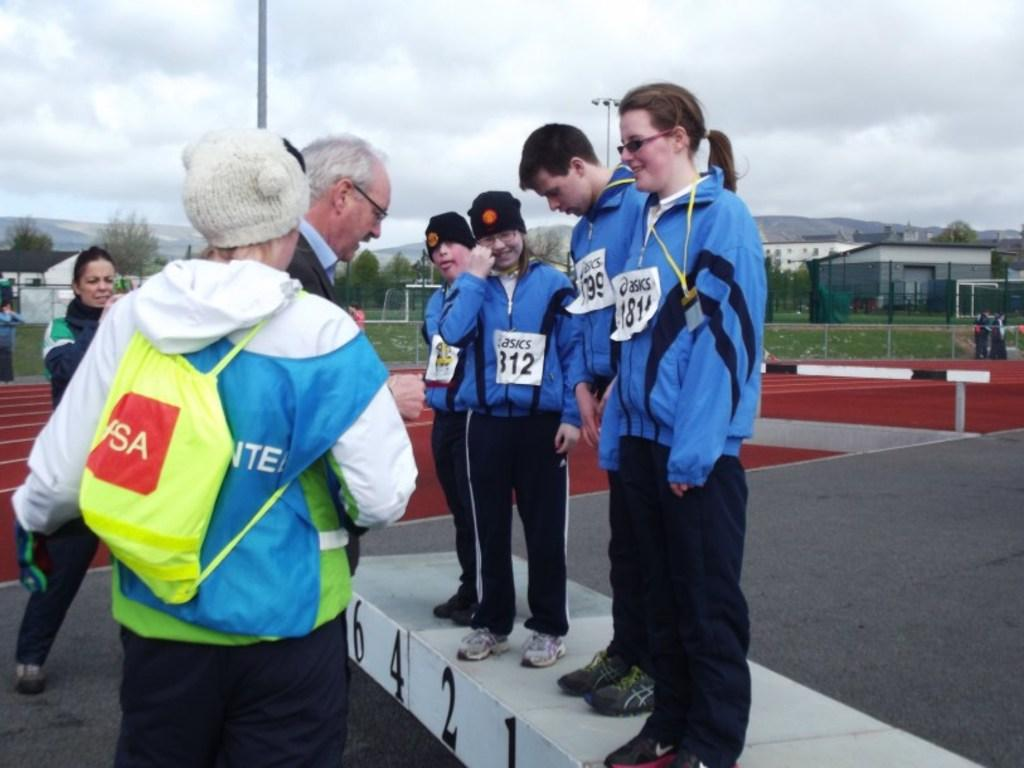<image>
Provide a brief description of the given image. one of the sponsors of the game is asics 